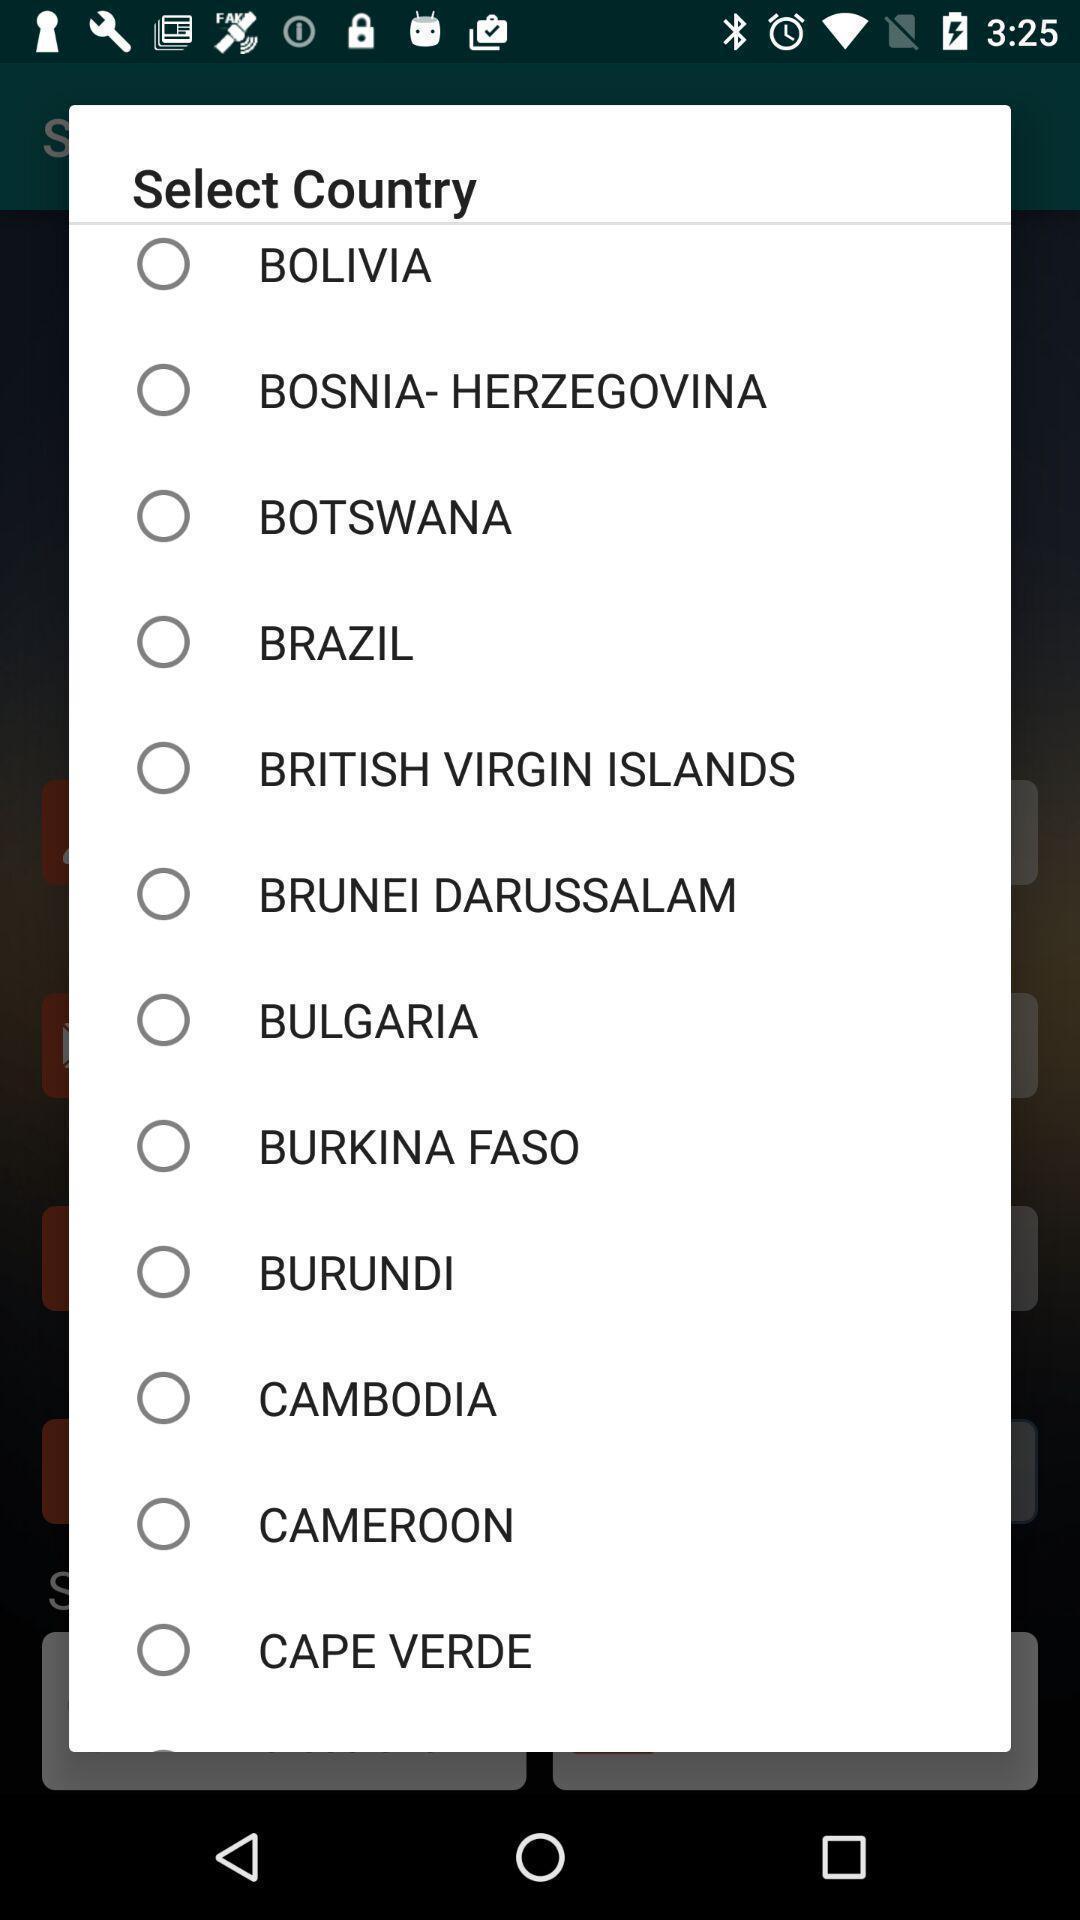Please provide a description for this image. Pop-up asking to choose a country. 